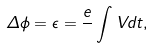<formula> <loc_0><loc_0><loc_500><loc_500>\Delta \phi = \epsilon = \frac { e } { } \int V d t ,</formula> 